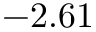<formula> <loc_0><loc_0><loc_500><loc_500>- 2 . 6 1</formula> 